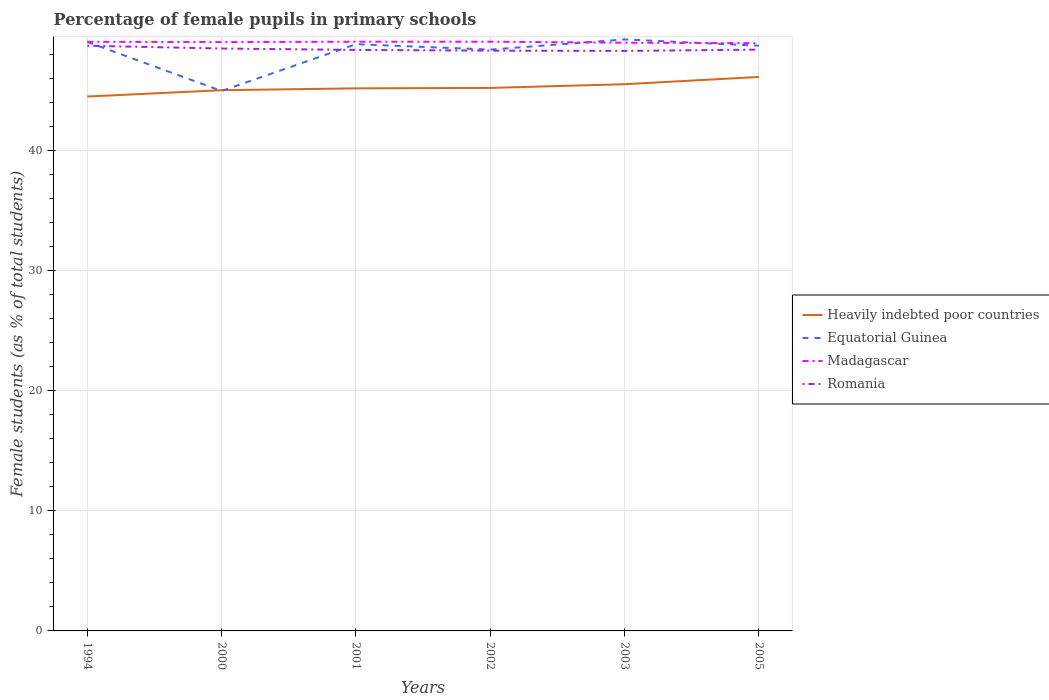Is the number of lines equal to the number of legend labels?
Keep it short and to the point. Yes. Across all years, what is the maximum percentage of female pupils in primary schools in Equatorial Guinea?
Give a very brief answer. 44.93. In which year was the percentage of female pupils in primary schools in Romania maximum?
Ensure brevity in your answer.  2003. What is the total percentage of female pupils in primary schools in Equatorial Guinea in the graph?
Ensure brevity in your answer.  -0.85. What is the difference between the highest and the second highest percentage of female pupils in primary schools in Heavily indebted poor countries?
Your answer should be very brief. 1.63. What is the difference between the highest and the lowest percentage of female pupils in primary schools in Heavily indebted poor countries?
Ensure brevity in your answer.  2. How many years are there in the graph?
Offer a very short reply. 6. Are the values on the major ticks of Y-axis written in scientific E-notation?
Give a very brief answer. No. Does the graph contain any zero values?
Provide a succinct answer. No. Does the graph contain grids?
Offer a very short reply. Yes. Where does the legend appear in the graph?
Offer a terse response. Center right. How are the legend labels stacked?
Provide a short and direct response. Vertical. What is the title of the graph?
Give a very brief answer. Percentage of female pupils in primary schools. Does "Lebanon" appear as one of the legend labels in the graph?
Your answer should be compact. No. What is the label or title of the X-axis?
Offer a terse response. Years. What is the label or title of the Y-axis?
Your response must be concise. Female students (as % of total students). What is the Female students (as % of total students) in Heavily indebted poor countries in 1994?
Offer a terse response. 44.47. What is the Female students (as % of total students) in Equatorial Guinea in 1994?
Provide a succinct answer. 49.01. What is the Female students (as % of total students) of Madagascar in 1994?
Provide a succinct answer. 49.02. What is the Female students (as % of total students) in Romania in 1994?
Your response must be concise. 48.7. What is the Female students (as % of total students) of Heavily indebted poor countries in 2000?
Your answer should be very brief. 44.99. What is the Female students (as % of total students) in Equatorial Guinea in 2000?
Ensure brevity in your answer.  44.93. What is the Female students (as % of total students) of Madagascar in 2000?
Offer a terse response. 49. What is the Female students (as % of total students) in Romania in 2000?
Keep it short and to the point. 48.46. What is the Female students (as % of total students) of Heavily indebted poor countries in 2001?
Offer a terse response. 45.15. What is the Female students (as % of total students) in Equatorial Guinea in 2001?
Make the answer very short. 48.82. What is the Female students (as % of total students) in Madagascar in 2001?
Offer a terse response. 49.03. What is the Female students (as % of total students) of Romania in 2001?
Your answer should be very brief. 48.35. What is the Female students (as % of total students) in Heavily indebted poor countries in 2002?
Ensure brevity in your answer.  45.18. What is the Female students (as % of total students) of Equatorial Guinea in 2002?
Give a very brief answer. 48.37. What is the Female students (as % of total students) of Madagascar in 2002?
Provide a short and direct response. 49.03. What is the Female students (as % of total students) in Romania in 2002?
Provide a succinct answer. 48.29. What is the Female students (as % of total students) of Heavily indebted poor countries in 2003?
Your answer should be very brief. 45.49. What is the Female students (as % of total students) in Equatorial Guinea in 2003?
Your answer should be very brief. 49.22. What is the Female students (as % of total students) of Madagascar in 2003?
Offer a terse response. 48.95. What is the Female students (as % of total students) of Romania in 2003?
Provide a short and direct response. 48.26. What is the Female students (as % of total students) in Heavily indebted poor countries in 2005?
Provide a short and direct response. 46.1. What is the Female students (as % of total students) of Equatorial Guinea in 2005?
Your answer should be very brief. 48.7. What is the Female students (as % of total students) of Madagascar in 2005?
Give a very brief answer. 48.91. What is the Female students (as % of total students) of Romania in 2005?
Give a very brief answer. 48.37. Across all years, what is the maximum Female students (as % of total students) of Heavily indebted poor countries?
Offer a very short reply. 46.1. Across all years, what is the maximum Female students (as % of total students) in Equatorial Guinea?
Provide a succinct answer. 49.22. Across all years, what is the maximum Female students (as % of total students) in Madagascar?
Keep it short and to the point. 49.03. Across all years, what is the maximum Female students (as % of total students) in Romania?
Provide a short and direct response. 48.7. Across all years, what is the minimum Female students (as % of total students) of Heavily indebted poor countries?
Your response must be concise. 44.47. Across all years, what is the minimum Female students (as % of total students) in Equatorial Guinea?
Give a very brief answer. 44.93. Across all years, what is the minimum Female students (as % of total students) of Madagascar?
Give a very brief answer. 48.91. Across all years, what is the minimum Female students (as % of total students) in Romania?
Give a very brief answer. 48.26. What is the total Female students (as % of total students) of Heavily indebted poor countries in the graph?
Your answer should be compact. 271.39. What is the total Female students (as % of total students) of Equatorial Guinea in the graph?
Your answer should be compact. 289.06. What is the total Female students (as % of total students) of Madagascar in the graph?
Make the answer very short. 293.93. What is the total Female students (as % of total students) in Romania in the graph?
Your answer should be compact. 290.43. What is the difference between the Female students (as % of total students) in Heavily indebted poor countries in 1994 and that in 2000?
Give a very brief answer. -0.53. What is the difference between the Female students (as % of total students) of Equatorial Guinea in 1994 and that in 2000?
Provide a short and direct response. 4.08. What is the difference between the Female students (as % of total students) of Madagascar in 1994 and that in 2000?
Keep it short and to the point. 0.03. What is the difference between the Female students (as % of total students) of Romania in 1994 and that in 2000?
Your answer should be compact. 0.23. What is the difference between the Female students (as % of total students) in Heavily indebted poor countries in 1994 and that in 2001?
Give a very brief answer. -0.68. What is the difference between the Female students (as % of total students) in Equatorial Guinea in 1994 and that in 2001?
Your answer should be compact. 0.19. What is the difference between the Female students (as % of total students) in Madagascar in 1994 and that in 2001?
Offer a terse response. -0.01. What is the difference between the Female students (as % of total students) in Romania in 1994 and that in 2001?
Your response must be concise. 0.35. What is the difference between the Female students (as % of total students) in Heavily indebted poor countries in 1994 and that in 2002?
Offer a very short reply. -0.72. What is the difference between the Female students (as % of total students) in Equatorial Guinea in 1994 and that in 2002?
Offer a terse response. 0.64. What is the difference between the Female students (as % of total students) in Madagascar in 1994 and that in 2002?
Your response must be concise. -0.01. What is the difference between the Female students (as % of total students) of Romania in 1994 and that in 2002?
Provide a short and direct response. 0.41. What is the difference between the Female students (as % of total students) in Heavily indebted poor countries in 1994 and that in 2003?
Provide a succinct answer. -1.02. What is the difference between the Female students (as % of total students) in Equatorial Guinea in 1994 and that in 2003?
Provide a succinct answer. -0.21. What is the difference between the Female students (as % of total students) of Madagascar in 1994 and that in 2003?
Give a very brief answer. 0.08. What is the difference between the Female students (as % of total students) in Romania in 1994 and that in 2003?
Provide a short and direct response. 0.43. What is the difference between the Female students (as % of total students) in Heavily indebted poor countries in 1994 and that in 2005?
Your answer should be very brief. -1.63. What is the difference between the Female students (as % of total students) of Equatorial Guinea in 1994 and that in 2005?
Offer a very short reply. 0.31. What is the difference between the Female students (as % of total students) of Madagascar in 1994 and that in 2005?
Make the answer very short. 0.12. What is the difference between the Female students (as % of total students) of Romania in 1994 and that in 2005?
Ensure brevity in your answer.  0.32. What is the difference between the Female students (as % of total students) of Heavily indebted poor countries in 2000 and that in 2001?
Offer a very short reply. -0.15. What is the difference between the Female students (as % of total students) of Equatorial Guinea in 2000 and that in 2001?
Provide a succinct answer. -3.89. What is the difference between the Female students (as % of total students) of Madagascar in 2000 and that in 2001?
Make the answer very short. -0.03. What is the difference between the Female students (as % of total students) of Romania in 2000 and that in 2001?
Ensure brevity in your answer.  0.12. What is the difference between the Female students (as % of total students) in Heavily indebted poor countries in 2000 and that in 2002?
Ensure brevity in your answer.  -0.19. What is the difference between the Female students (as % of total students) of Equatorial Guinea in 2000 and that in 2002?
Provide a short and direct response. -3.44. What is the difference between the Female students (as % of total students) in Madagascar in 2000 and that in 2002?
Your answer should be compact. -0.03. What is the difference between the Female students (as % of total students) of Romania in 2000 and that in 2002?
Your response must be concise. 0.18. What is the difference between the Female students (as % of total students) of Heavily indebted poor countries in 2000 and that in 2003?
Offer a terse response. -0.5. What is the difference between the Female students (as % of total students) in Equatorial Guinea in 2000 and that in 2003?
Your response must be concise. -4.29. What is the difference between the Female students (as % of total students) in Madagascar in 2000 and that in 2003?
Keep it short and to the point. 0.05. What is the difference between the Female students (as % of total students) of Romania in 2000 and that in 2003?
Provide a succinct answer. 0.2. What is the difference between the Female students (as % of total students) of Heavily indebted poor countries in 2000 and that in 2005?
Your answer should be compact. -1.1. What is the difference between the Female students (as % of total students) of Equatorial Guinea in 2000 and that in 2005?
Offer a terse response. -3.77. What is the difference between the Female students (as % of total students) in Madagascar in 2000 and that in 2005?
Offer a very short reply. 0.09. What is the difference between the Female students (as % of total students) of Romania in 2000 and that in 2005?
Offer a very short reply. 0.09. What is the difference between the Female students (as % of total students) of Heavily indebted poor countries in 2001 and that in 2002?
Offer a very short reply. -0.04. What is the difference between the Female students (as % of total students) of Equatorial Guinea in 2001 and that in 2002?
Your answer should be very brief. 0.45. What is the difference between the Female students (as % of total students) of Madagascar in 2001 and that in 2002?
Your response must be concise. 0. What is the difference between the Female students (as % of total students) of Romania in 2001 and that in 2002?
Your answer should be very brief. 0.06. What is the difference between the Female students (as % of total students) in Heavily indebted poor countries in 2001 and that in 2003?
Make the answer very short. -0.35. What is the difference between the Female students (as % of total students) in Equatorial Guinea in 2001 and that in 2003?
Provide a short and direct response. -0.4. What is the difference between the Female students (as % of total students) of Madagascar in 2001 and that in 2003?
Give a very brief answer. 0.08. What is the difference between the Female students (as % of total students) in Romania in 2001 and that in 2003?
Give a very brief answer. 0.08. What is the difference between the Female students (as % of total students) in Heavily indebted poor countries in 2001 and that in 2005?
Provide a short and direct response. -0.95. What is the difference between the Female students (as % of total students) of Equatorial Guinea in 2001 and that in 2005?
Ensure brevity in your answer.  0.13. What is the difference between the Female students (as % of total students) in Madagascar in 2001 and that in 2005?
Ensure brevity in your answer.  0.12. What is the difference between the Female students (as % of total students) in Romania in 2001 and that in 2005?
Your answer should be compact. -0.03. What is the difference between the Female students (as % of total students) in Heavily indebted poor countries in 2002 and that in 2003?
Provide a succinct answer. -0.31. What is the difference between the Female students (as % of total students) of Equatorial Guinea in 2002 and that in 2003?
Your response must be concise. -0.85. What is the difference between the Female students (as % of total students) of Madagascar in 2002 and that in 2003?
Give a very brief answer. 0.08. What is the difference between the Female students (as % of total students) in Romania in 2002 and that in 2003?
Your answer should be compact. 0.02. What is the difference between the Female students (as % of total students) in Heavily indebted poor countries in 2002 and that in 2005?
Your answer should be very brief. -0.91. What is the difference between the Female students (as % of total students) of Equatorial Guinea in 2002 and that in 2005?
Make the answer very short. -0.32. What is the difference between the Female students (as % of total students) in Madagascar in 2002 and that in 2005?
Offer a terse response. 0.12. What is the difference between the Female students (as % of total students) in Romania in 2002 and that in 2005?
Your answer should be compact. -0.09. What is the difference between the Female students (as % of total students) in Heavily indebted poor countries in 2003 and that in 2005?
Offer a terse response. -0.6. What is the difference between the Female students (as % of total students) in Equatorial Guinea in 2003 and that in 2005?
Provide a succinct answer. 0.52. What is the difference between the Female students (as % of total students) in Madagascar in 2003 and that in 2005?
Ensure brevity in your answer.  0.04. What is the difference between the Female students (as % of total students) of Romania in 2003 and that in 2005?
Keep it short and to the point. -0.11. What is the difference between the Female students (as % of total students) in Heavily indebted poor countries in 1994 and the Female students (as % of total students) in Equatorial Guinea in 2000?
Your answer should be compact. -0.46. What is the difference between the Female students (as % of total students) of Heavily indebted poor countries in 1994 and the Female students (as % of total students) of Madagascar in 2000?
Give a very brief answer. -4.53. What is the difference between the Female students (as % of total students) of Heavily indebted poor countries in 1994 and the Female students (as % of total students) of Romania in 2000?
Offer a very short reply. -3.99. What is the difference between the Female students (as % of total students) of Equatorial Guinea in 1994 and the Female students (as % of total students) of Madagascar in 2000?
Provide a short and direct response. 0.01. What is the difference between the Female students (as % of total students) in Equatorial Guinea in 1994 and the Female students (as % of total students) in Romania in 2000?
Provide a short and direct response. 0.55. What is the difference between the Female students (as % of total students) of Madagascar in 1994 and the Female students (as % of total students) of Romania in 2000?
Offer a terse response. 0.56. What is the difference between the Female students (as % of total students) of Heavily indebted poor countries in 1994 and the Female students (as % of total students) of Equatorial Guinea in 2001?
Keep it short and to the point. -4.35. What is the difference between the Female students (as % of total students) of Heavily indebted poor countries in 1994 and the Female students (as % of total students) of Madagascar in 2001?
Your response must be concise. -4.56. What is the difference between the Female students (as % of total students) of Heavily indebted poor countries in 1994 and the Female students (as % of total students) of Romania in 2001?
Offer a very short reply. -3.88. What is the difference between the Female students (as % of total students) in Equatorial Guinea in 1994 and the Female students (as % of total students) in Madagascar in 2001?
Your response must be concise. -0.02. What is the difference between the Female students (as % of total students) of Equatorial Guinea in 1994 and the Female students (as % of total students) of Romania in 2001?
Your answer should be compact. 0.67. What is the difference between the Female students (as % of total students) in Madagascar in 1994 and the Female students (as % of total students) in Romania in 2001?
Provide a short and direct response. 0.68. What is the difference between the Female students (as % of total students) of Heavily indebted poor countries in 1994 and the Female students (as % of total students) of Equatorial Guinea in 2002?
Offer a very short reply. -3.91. What is the difference between the Female students (as % of total students) of Heavily indebted poor countries in 1994 and the Female students (as % of total students) of Madagascar in 2002?
Keep it short and to the point. -4.56. What is the difference between the Female students (as % of total students) of Heavily indebted poor countries in 1994 and the Female students (as % of total students) of Romania in 2002?
Your answer should be very brief. -3.82. What is the difference between the Female students (as % of total students) in Equatorial Guinea in 1994 and the Female students (as % of total students) in Madagascar in 2002?
Offer a terse response. -0.02. What is the difference between the Female students (as % of total students) of Equatorial Guinea in 1994 and the Female students (as % of total students) of Romania in 2002?
Offer a terse response. 0.73. What is the difference between the Female students (as % of total students) of Madagascar in 1994 and the Female students (as % of total students) of Romania in 2002?
Your response must be concise. 0.74. What is the difference between the Female students (as % of total students) of Heavily indebted poor countries in 1994 and the Female students (as % of total students) of Equatorial Guinea in 2003?
Keep it short and to the point. -4.75. What is the difference between the Female students (as % of total students) of Heavily indebted poor countries in 1994 and the Female students (as % of total students) of Madagascar in 2003?
Ensure brevity in your answer.  -4.48. What is the difference between the Female students (as % of total students) in Heavily indebted poor countries in 1994 and the Female students (as % of total students) in Romania in 2003?
Keep it short and to the point. -3.79. What is the difference between the Female students (as % of total students) of Equatorial Guinea in 1994 and the Female students (as % of total students) of Madagascar in 2003?
Your response must be concise. 0.07. What is the difference between the Female students (as % of total students) of Equatorial Guinea in 1994 and the Female students (as % of total students) of Romania in 2003?
Provide a short and direct response. 0.75. What is the difference between the Female students (as % of total students) in Madagascar in 1994 and the Female students (as % of total students) in Romania in 2003?
Provide a succinct answer. 0.76. What is the difference between the Female students (as % of total students) of Heavily indebted poor countries in 1994 and the Female students (as % of total students) of Equatorial Guinea in 2005?
Offer a terse response. -4.23. What is the difference between the Female students (as % of total students) in Heavily indebted poor countries in 1994 and the Female students (as % of total students) in Madagascar in 2005?
Offer a terse response. -4.44. What is the difference between the Female students (as % of total students) in Heavily indebted poor countries in 1994 and the Female students (as % of total students) in Romania in 2005?
Your answer should be compact. -3.9. What is the difference between the Female students (as % of total students) of Equatorial Guinea in 1994 and the Female students (as % of total students) of Madagascar in 2005?
Offer a terse response. 0.11. What is the difference between the Female students (as % of total students) of Equatorial Guinea in 1994 and the Female students (as % of total students) of Romania in 2005?
Provide a short and direct response. 0.64. What is the difference between the Female students (as % of total students) in Madagascar in 1994 and the Female students (as % of total students) in Romania in 2005?
Offer a terse response. 0.65. What is the difference between the Female students (as % of total students) of Heavily indebted poor countries in 2000 and the Female students (as % of total students) of Equatorial Guinea in 2001?
Keep it short and to the point. -3.83. What is the difference between the Female students (as % of total students) in Heavily indebted poor countries in 2000 and the Female students (as % of total students) in Madagascar in 2001?
Your response must be concise. -4.04. What is the difference between the Female students (as % of total students) in Heavily indebted poor countries in 2000 and the Female students (as % of total students) in Romania in 2001?
Provide a succinct answer. -3.35. What is the difference between the Female students (as % of total students) of Equatorial Guinea in 2000 and the Female students (as % of total students) of Madagascar in 2001?
Keep it short and to the point. -4.1. What is the difference between the Female students (as % of total students) of Equatorial Guinea in 2000 and the Female students (as % of total students) of Romania in 2001?
Offer a very short reply. -3.42. What is the difference between the Female students (as % of total students) in Madagascar in 2000 and the Female students (as % of total students) in Romania in 2001?
Your answer should be very brief. 0.65. What is the difference between the Female students (as % of total students) in Heavily indebted poor countries in 2000 and the Female students (as % of total students) in Equatorial Guinea in 2002?
Offer a terse response. -3.38. What is the difference between the Female students (as % of total students) in Heavily indebted poor countries in 2000 and the Female students (as % of total students) in Madagascar in 2002?
Provide a short and direct response. -4.04. What is the difference between the Female students (as % of total students) in Heavily indebted poor countries in 2000 and the Female students (as % of total students) in Romania in 2002?
Provide a succinct answer. -3.29. What is the difference between the Female students (as % of total students) of Equatorial Guinea in 2000 and the Female students (as % of total students) of Madagascar in 2002?
Make the answer very short. -4.1. What is the difference between the Female students (as % of total students) of Equatorial Guinea in 2000 and the Female students (as % of total students) of Romania in 2002?
Your response must be concise. -3.36. What is the difference between the Female students (as % of total students) of Madagascar in 2000 and the Female students (as % of total students) of Romania in 2002?
Ensure brevity in your answer.  0.71. What is the difference between the Female students (as % of total students) of Heavily indebted poor countries in 2000 and the Female students (as % of total students) of Equatorial Guinea in 2003?
Offer a very short reply. -4.23. What is the difference between the Female students (as % of total students) in Heavily indebted poor countries in 2000 and the Female students (as % of total students) in Madagascar in 2003?
Your response must be concise. -3.95. What is the difference between the Female students (as % of total students) of Heavily indebted poor countries in 2000 and the Female students (as % of total students) of Romania in 2003?
Offer a terse response. -3.27. What is the difference between the Female students (as % of total students) of Equatorial Guinea in 2000 and the Female students (as % of total students) of Madagascar in 2003?
Provide a succinct answer. -4.02. What is the difference between the Female students (as % of total students) of Equatorial Guinea in 2000 and the Female students (as % of total students) of Romania in 2003?
Your answer should be compact. -3.33. What is the difference between the Female students (as % of total students) in Madagascar in 2000 and the Female students (as % of total students) in Romania in 2003?
Your response must be concise. 0.73. What is the difference between the Female students (as % of total students) of Heavily indebted poor countries in 2000 and the Female students (as % of total students) of Equatorial Guinea in 2005?
Offer a very short reply. -3.7. What is the difference between the Female students (as % of total students) in Heavily indebted poor countries in 2000 and the Female students (as % of total students) in Madagascar in 2005?
Your response must be concise. -3.91. What is the difference between the Female students (as % of total students) of Heavily indebted poor countries in 2000 and the Female students (as % of total students) of Romania in 2005?
Give a very brief answer. -3.38. What is the difference between the Female students (as % of total students) in Equatorial Guinea in 2000 and the Female students (as % of total students) in Madagascar in 2005?
Give a very brief answer. -3.97. What is the difference between the Female students (as % of total students) of Equatorial Guinea in 2000 and the Female students (as % of total students) of Romania in 2005?
Provide a succinct answer. -3.44. What is the difference between the Female students (as % of total students) in Madagascar in 2000 and the Female students (as % of total students) in Romania in 2005?
Ensure brevity in your answer.  0.63. What is the difference between the Female students (as % of total students) in Heavily indebted poor countries in 2001 and the Female students (as % of total students) in Equatorial Guinea in 2002?
Your response must be concise. -3.23. What is the difference between the Female students (as % of total students) in Heavily indebted poor countries in 2001 and the Female students (as % of total students) in Madagascar in 2002?
Your answer should be very brief. -3.88. What is the difference between the Female students (as % of total students) of Heavily indebted poor countries in 2001 and the Female students (as % of total students) of Romania in 2002?
Make the answer very short. -3.14. What is the difference between the Female students (as % of total students) of Equatorial Guinea in 2001 and the Female students (as % of total students) of Madagascar in 2002?
Your response must be concise. -0.21. What is the difference between the Female students (as % of total students) of Equatorial Guinea in 2001 and the Female students (as % of total students) of Romania in 2002?
Ensure brevity in your answer.  0.54. What is the difference between the Female students (as % of total students) in Madagascar in 2001 and the Female students (as % of total students) in Romania in 2002?
Ensure brevity in your answer.  0.74. What is the difference between the Female students (as % of total students) in Heavily indebted poor countries in 2001 and the Female students (as % of total students) in Equatorial Guinea in 2003?
Your answer should be very brief. -4.07. What is the difference between the Female students (as % of total students) of Heavily indebted poor countries in 2001 and the Female students (as % of total students) of Madagascar in 2003?
Your answer should be very brief. -3.8. What is the difference between the Female students (as % of total students) in Heavily indebted poor countries in 2001 and the Female students (as % of total students) in Romania in 2003?
Provide a short and direct response. -3.11. What is the difference between the Female students (as % of total students) of Equatorial Guinea in 2001 and the Female students (as % of total students) of Madagascar in 2003?
Offer a terse response. -0.12. What is the difference between the Female students (as % of total students) of Equatorial Guinea in 2001 and the Female students (as % of total students) of Romania in 2003?
Provide a short and direct response. 0.56. What is the difference between the Female students (as % of total students) of Madagascar in 2001 and the Female students (as % of total students) of Romania in 2003?
Offer a very short reply. 0.77. What is the difference between the Female students (as % of total students) in Heavily indebted poor countries in 2001 and the Female students (as % of total students) in Equatorial Guinea in 2005?
Your response must be concise. -3.55. What is the difference between the Female students (as % of total students) of Heavily indebted poor countries in 2001 and the Female students (as % of total students) of Madagascar in 2005?
Provide a succinct answer. -3.76. What is the difference between the Female students (as % of total students) of Heavily indebted poor countries in 2001 and the Female students (as % of total students) of Romania in 2005?
Provide a succinct answer. -3.22. What is the difference between the Female students (as % of total students) of Equatorial Guinea in 2001 and the Female students (as % of total students) of Madagascar in 2005?
Offer a very short reply. -0.08. What is the difference between the Female students (as % of total students) in Equatorial Guinea in 2001 and the Female students (as % of total students) in Romania in 2005?
Provide a short and direct response. 0.45. What is the difference between the Female students (as % of total students) in Madagascar in 2001 and the Female students (as % of total students) in Romania in 2005?
Provide a succinct answer. 0.66. What is the difference between the Female students (as % of total students) in Heavily indebted poor countries in 2002 and the Female students (as % of total students) in Equatorial Guinea in 2003?
Keep it short and to the point. -4.04. What is the difference between the Female students (as % of total students) of Heavily indebted poor countries in 2002 and the Female students (as % of total students) of Madagascar in 2003?
Your response must be concise. -3.76. What is the difference between the Female students (as % of total students) of Heavily indebted poor countries in 2002 and the Female students (as % of total students) of Romania in 2003?
Your response must be concise. -3.08. What is the difference between the Female students (as % of total students) of Equatorial Guinea in 2002 and the Female students (as % of total students) of Madagascar in 2003?
Offer a very short reply. -0.57. What is the difference between the Female students (as % of total students) in Equatorial Guinea in 2002 and the Female students (as % of total students) in Romania in 2003?
Provide a succinct answer. 0.11. What is the difference between the Female students (as % of total students) of Madagascar in 2002 and the Female students (as % of total students) of Romania in 2003?
Make the answer very short. 0.77. What is the difference between the Female students (as % of total students) in Heavily indebted poor countries in 2002 and the Female students (as % of total students) in Equatorial Guinea in 2005?
Your answer should be compact. -3.51. What is the difference between the Female students (as % of total students) of Heavily indebted poor countries in 2002 and the Female students (as % of total students) of Madagascar in 2005?
Your answer should be very brief. -3.72. What is the difference between the Female students (as % of total students) of Heavily indebted poor countries in 2002 and the Female students (as % of total students) of Romania in 2005?
Provide a succinct answer. -3.19. What is the difference between the Female students (as % of total students) in Equatorial Guinea in 2002 and the Female students (as % of total students) in Madagascar in 2005?
Keep it short and to the point. -0.53. What is the difference between the Female students (as % of total students) in Equatorial Guinea in 2002 and the Female students (as % of total students) in Romania in 2005?
Offer a terse response. 0. What is the difference between the Female students (as % of total students) of Madagascar in 2002 and the Female students (as % of total students) of Romania in 2005?
Provide a short and direct response. 0.66. What is the difference between the Female students (as % of total students) in Heavily indebted poor countries in 2003 and the Female students (as % of total students) in Equatorial Guinea in 2005?
Your response must be concise. -3.2. What is the difference between the Female students (as % of total students) of Heavily indebted poor countries in 2003 and the Female students (as % of total students) of Madagascar in 2005?
Your answer should be compact. -3.41. What is the difference between the Female students (as % of total students) of Heavily indebted poor countries in 2003 and the Female students (as % of total students) of Romania in 2005?
Your response must be concise. -2.88. What is the difference between the Female students (as % of total students) of Equatorial Guinea in 2003 and the Female students (as % of total students) of Madagascar in 2005?
Make the answer very short. 0.31. What is the difference between the Female students (as % of total students) in Equatorial Guinea in 2003 and the Female students (as % of total students) in Romania in 2005?
Your response must be concise. 0.85. What is the difference between the Female students (as % of total students) in Madagascar in 2003 and the Female students (as % of total students) in Romania in 2005?
Your answer should be very brief. 0.57. What is the average Female students (as % of total students) in Heavily indebted poor countries per year?
Keep it short and to the point. 45.23. What is the average Female students (as % of total students) in Equatorial Guinea per year?
Your answer should be very brief. 48.18. What is the average Female students (as % of total students) of Madagascar per year?
Your answer should be compact. 48.99. What is the average Female students (as % of total students) of Romania per year?
Give a very brief answer. 48.4. In the year 1994, what is the difference between the Female students (as % of total students) of Heavily indebted poor countries and Female students (as % of total students) of Equatorial Guinea?
Your answer should be very brief. -4.54. In the year 1994, what is the difference between the Female students (as % of total students) in Heavily indebted poor countries and Female students (as % of total students) in Madagascar?
Keep it short and to the point. -4.55. In the year 1994, what is the difference between the Female students (as % of total students) of Heavily indebted poor countries and Female students (as % of total students) of Romania?
Your answer should be very brief. -4.23. In the year 1994, what is the difference between the Female students (as % of total students) in Equatorial Guinea and Female students (as % of total students) in Madagascar?
Provide a short and direct response. -0.01. In the year 1994, what is the difference between the Female students (as % of total students) of Equatorial Guinea and Female students (as % of total students) of Romania?
Provide a succinct answer. 0.32. In the year 1994, what is the difference between the Female students (as % of total students) of Madagascar and Female students (as % of total students) of Romania?
Provide a short and direct response. 0.33. In the year 2000, what is the difference between the Female students (as % of total students) in Heavily indebted poor countries and Female students (as % of total students) in Equatorial Guinea?
Offer a very short reply. 0.06. In the year 2000, what is the difference between the Female students (as % of total students) of Heavily indebted poor countries and Female students (as % of total students) of Madagascar?
Offer a terse response. -4. In the year 2000, what is the difference between the Female students (as % of total students) of Heavily indebted poor countries and Female students (as % of total students) of Romania?
Keep it short and to the point. -3.47. In the year 2000, what is the difference between the Female students (as % of total students) in Equatorial Guinea and Female students (as % of total students) in Madagascar?
Offer a terse response. -4.07. In the year 2000, what is the difference between the Female students (as % of total students) of Equatorial Guinea and Female students (as % of total students) of Romania?
Your answer should be compact. -3.53. In the year 2000, what is the difference between the Female students (as % of total students) of Madagascar and Female students (as % of total students) of Romania?
Your answer should be very brief. 0.53. In the year 2001, what is the difference between the Female students (as % of total students) in Heavily indebted poor countries and Female students (as % of total students) in Equatorial Guinea?
Your response must be concise. -3.67. In the year 2001, what is the difference between the Female students (as % of total students) of Heavily indebted poor countries and Female students (as % of total students) of Madagascar?
Your answer should be compact. -3.88. In the year 2001, what is the difference between the Female students (as % of total students) of Heavily indebted poor countries and Female students (as % of total students) of Romania?
Provide a succinct answer. -3.2. In the year 2001, what is the difference between the Female students (as % of total students) of Equatorial Guinea and Female students (as % of total students) of Madagascar?
Your response must be concise. -0.21. In the year 2001, what is the difference between the Female students (as % of total students) of Equatorial Guinea and Female students (as % of total students) of Romania?
Ensure brevity in your answer.  0.48. In the year 2001, what is the difference between the Female students (as % of total students) of Madagascar and Female students (as % of total students) of Romania?
Give a very brief answer. 0.68. In the year 2002, what is the difference between the Female students (as % of total students) of Heavily indebted poor countries and Female students (as % of total students) of Equatorial Guinea?
Offer a very short reply. -3.19. In the year 2002, what is the difference between the Female students (as % of total students) of Heavily indebted poor countries and Female students (as % of total students) of Madagascar?
Your answer should be compact. -3.85. In the year 2002, what is the difference between the Female students (as % of total students) in Heavily indebted poor countries and Female students (as % of total students) in Romania?
Ensure brevity in your answer.  -3.1. In the year 2002, what is the difference between the Female students (as % of total students) in Equatorial Guinea and Female students (as % of total students) in Madagascar?
Give a very brief answer. -0.66. In the year 2002, what is the difference between the Female students (as % of total students) in Equatorial Guinea and Female students (as % of total students) in Romania?
Provide a succinct answer. 0.09. In the year 2002, what is the difference between the Female students (as % of total students) in Madagascar and Female students (as % of total students) in Romania?
Provide a short and direct response. 0.74. In the year 2003, what is the difference between the Female students (as % of total students) in Heavily indebted poor countries and Female students (as % of total students) in Equatorial Guinea?
Make the answer very short. -3.73. In the year 2003, what is the difference between the Female students (as % of total students) in Heavily indebted poor countries and Female students (as % of total students) in Madagascar?
Your answer should be very brief. -3.45. In the year 2003, what is the difference between the Female students (as % of total students) of Heavily indebted poor countries and Female students (as % of total students) of Romania?
Give a very brief answer. -2.77. In the year 2003, what is the difference between the Female students (as % of total students) of Equatorial Guinea and Female students (as % of total students) of Madagascar?
Ensure brevity in your answer.  0.27. In the year 2003, what is the difference between the Female students (as % of total students) of Equatorial Guinea and Female students (as % of total students) of Romania?
Give a very brief answer. 0.96. In the year 2003, what is the difference between the Female students (as % of total students) of Madagascar and Female students (as % of total students) of Romania?
Keep it short and to the point. 0.68. In the year 2005, what is the difference between the Female students (as % of total students) of Heavily indebted poor countries and Female students (as % of total students) of Equatorial Guinea?
Offer a very short reply. -2.6. In the year 2005, what is the difference between the Female students (as % of total students) in Heavily indebted poor countries and Female students (as % of total students) in Madagascar?
Give a very brief answer. -2.81. In the year 2005, what is the difference between the Female students (as % of total students) of Heavily indebted poor countries and Female students (as % of total students) of Romania?
Your answer should be compact. -2.27. In the year 2005, what is the difference between the Female students (as % of total students) of Equatorial Guinea and Female students (as % of total students) of Madagascar?
Provide a short and direct response. -0.21. In the year 2005, what is the difference between the Female students (as % of total students) of Equatorial Guinea and Female students (as % of total students) of Romania?
Offer a very short reply. 0.33. In the year 2005, what is the difference between the Female students (as % of total students) of Madagascar and Female students (as % of total students) of Romania?
Keep it short and to the point. 0.53. What is the ratio of the Female students (as % of total students) in Heavily indebted poor countries in 1994 to that in 2000?
Offer a very short reply. 0.99. What is the ratio of the Female students (as % of total students) in Equatorial Guinea in 1994 to that in 2000?
Your answer should be very brief. 1.09. What is the ratio of the Female students (as % of total students) in Romania in 1994 to that in 2000?
Ensure brevity in your answer.  1. What is the ratio of the Female students (as % of total students) in Heavily indebted poor countries in 1994 to that in 2001?
Offer a terse response. 0.98. What is the ratio of the Female students (as % of total students) of Madagascar in 1994 to that in 2001?
Your answer should be very brief. 1. What is the ratio of the Female students (as % of total students) in Romania in 1994 to that in 2001?
Provide a short and direct response. 1.01. What is the ratio of the Female students (as % of total students) of Heavily indebted poor countries in 1994 to that in 2002?
Make the answer very short. 0.98. What is the ratio of the Female students (as % of total students) of Equatorial Guinea in 1994 to that in 2002?
Your answer should be compact. 1.01. What is the ratio of the Female students (as % of total students) in Madagascar in 1994 to that in 2002?
Keep it short and to the point. 1. What is the ratio of the Female students (as % of total students) of Romania in 1994 to that in 2002?
Offer a very short reply. 1.01. What is the ratio of the Female students (as % of total students) of Heavily indebted poor countries in 1994 to that in 2003?
Give a very brief answer. 0.98. What is the ratio of the Female students (as % of total students) in Equatorial Guinea in 1994 to that in 2003?
Offer a very short reply. 1. What is the ratio of the Female students (as % of total students) of Madagascar in 1994 to that in 2003?
Provide a succinct answer. 1. What is the ratio of the Female students (as % of total students) in Heavily indebted poor countries in 1994 to that in 2005?
Provide a short and direct response. 0.96. What is the ratio of the Female students (as % of total students) in Madagascar in 1994 to that in 2005?
Provide a short and direct response. 1. What is the ratio of the Female students (as % of total students) in Romania in 1994 to that in 2005?
Keep it short and to the point. 1.01. What is the ratio of the Female students (as % of total students) of Heavily indebted poor countries in 2000 to that in 2001?
Make the answer very short. 1. What is the ratio of the Female students (as % of total students) in Equatorial Guinea in 2000 to that in 2001?
Give a very brief answer. 0.92. What is the ratio of the Female students (as % of total students) in Romania in 2000 to that in 2001?
Keep it short and to the point. 1. What is the ratio of the Female students (as % of total students) of Equatorial Guinea in 2000 to that in 2002?
Ensure brevity in your answer.  0.93. What is the ratio of the Female students (as % of total students) of Romania in 2000 to that in 2002?
Ensure brevity in your answer.  1. What is the ratio of the Female students (as % of total students) of Heavily indebted poor countries in 2000 to that in 2003?
Keep it short and to the point. 0.99. What is the ratio of the Female students (as % of total students) in Equatorial Guinea in 2000 to that in 2003?
Keep it short and to the point. 0.91. What is the ratio of the Female students (as % of total students) of Madagascar in 2000 to that in 2003?
Offer a terse response. 1. What is the ratio of the Female students (as % of total students) of Heavily indebted poor countries in 2000 to that in 2005?
Provide a succinct answer. 0.98. What is the ratio of the Female students (as % of total students) of Equatorial Guinea in 2000 to that in 2005?
Your answer should be very brief. 0.92. What is the ratio of the Female students (as % of total students) in Madagascar in 2000 to that in 2005?
Your answer should be compact. 1. What is the ratio of the Female students (as % of total students) in Romania in 2000 to that in 2005?
Provide a short and direct response. 1. What is the ratio of the Female students (as % of total students) in Equatorial Guinea in 2001 to that in 2002?
Provide a short and direct response. 1.01. What is the ratio of the Female students (as % of total students) in Romania in 2001 to that in 2002?
Give a very brief answer. 1. What is the ratio of the Female students (as % of total students) of Heavily indebted poor countries in 2001 to that in 2003?
Make the answer very short. 0.99. What is the ratio of the Female students (as % of total students) in Heavily indebted poor countries in 2001 to that in 2005?
Provide a short and direct response. 0.98. What is the ratio of the Female students (as % of total students) in Equatorial Guinea in 2001 to that in 2005?
Make the answer very short. 1. What is the ratio of the Female students (as % of total students) in Romania in 2001 to that in 2005?
Give a very brief answer. 1. What is the ratio of the Female students (as % of total students) in Heavily indebted poor countries in 2002 to that in 2003?
Your answer should be very brief. 0.99. What is the ratio of the Female students (as % of total students) in Equatorial Guinea in 2002 to that in 2003?
Offer a terse response. 0.98. What is the ratio of the Female students (as % of total students) in Madagascar in 2002 to that in 2003?
Your response must be concise. 1. What is the ratio of the Female students (as % of total students) of Romania in 2002 to that in 2003?
Provide a succinct answer. 1. What is the ratio of the Female students (as % of total students) of Heavily indebted poor countries in 2002 to that in 2005?
Give a very brief answer. 0.98. What is the ratio of the Female students (as % of total students) in Equatorial Guinea in 2002 to that in 2005?
Keep it short and to the point. 0.99. What is the ratio of the Female students (as % of total students) of Madagascar in 2002 to that in 2005?
Provide a short and direct response. 1. What is the ratio of the Female students (as % of total students) in Heavily indebted poor countries in 2003 to that in 2005?
Your response must be concise. 0.99. What is the ratio of the Female students (as % of total students) in Equatorial Guinea in 2003 to that in 2005?
Keep it short and to the point. 1.01. What is the ratio of the Female students (as % of total students) of Madagascar in 2003 to that in 2005?
Offer a terse response. 1. What is the difference between the highest and the second highest Female students (as % of total students) of Heavily indebted poor countries?
Provide a short and direct response. 0.6. What is the difference between the highest and the second highest Female students (as % of total students) of Equatorial Guinea?
Ensure brevity in your answer.  0.21. What is the difference between the highest and the second highest Female students (as % of total students) in Romania?
Give a very brief answer. 0.23. What is the difference between the highest and the lowest Female students (as % of total students) in Heavily indebted poor countries?
Make the answer very short. 1.63. What is the difference between the highest and the lowest Female students (as % of total students) of Equatorial Guinea?
Provide a succinct answer. 4.29. What is the difference between the highest and the lowest Female students (as % of total students) of Madagascar?
Give a very brief answer. 0.12. What is the difference between the highest and the lowest Female students (as % of total students) in Romania?
Offer a terse response. 0.43. 